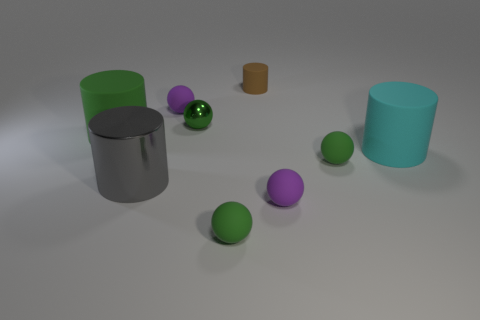Do these objects suggest any particular setting or do they seem placed at random? The objects appear to be placed intentionally with some space between them, suggesting a composed scene rather than a random setting. The placement could be part of a visual study of shapes and colors, or perhaps a setup for a rendering or 3D modeling practice. The neat and isolated arrangement doesn't imply any specific real-world setting. 